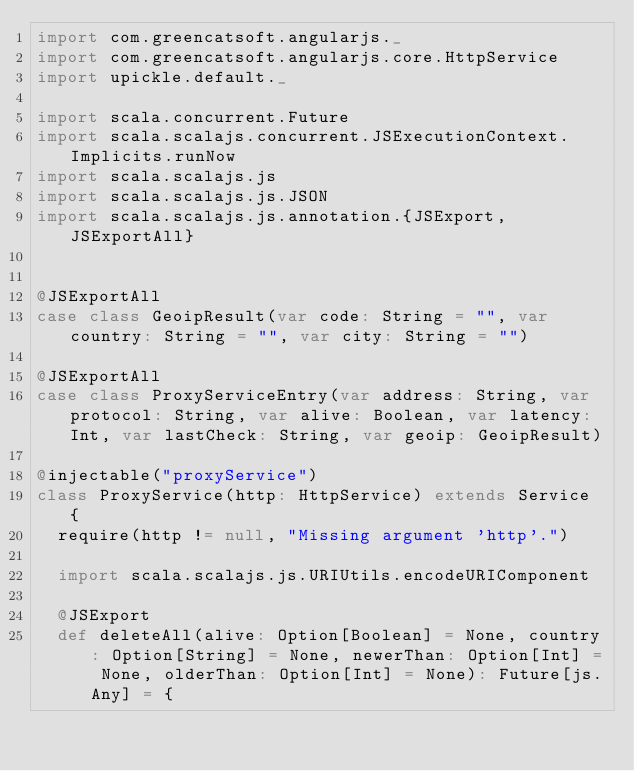<code> <loc_0><loc_0><loc_500><loc_500><_Scala_>import com.greencatsoft.angularjs._
import com.greencatsoft.angularjs.core.HttpService
import upickle.default._

import scala.concurrent.Future
import scala.scalajs.concurrent.JSExecutionContext.Implicits.runNow
import scala.scalajs.js
import scala.scalajs.js.JSON
import scala.scalajs.js.annotation.{JSExport, JSExportAll}


@JSExportAll
case class GeoipResult(var code: String = "", var country: String = "", var city: String = "")

@JSExportAll
case class ProxyServiceEntry(var address: String, var protocol: String, var alive: Boolean, var latency: Int, var lastCheck: String, var geoip: GeoipResult)

@injectable("proxyService")
class ProxyService(http: HttpService) extends Service {
  require(http != null, "Missing argument 'http'.")

  import scala.scalajs.js.URIUtils.encodeURIComponent

  @JSExport
  def deleteAll(alive: Option[Boolean] = None, country: Option[String] = None, newerThan: Option[Int] = None, olderThan: Option[Int] = None): Future[js.Any] = {</code> 